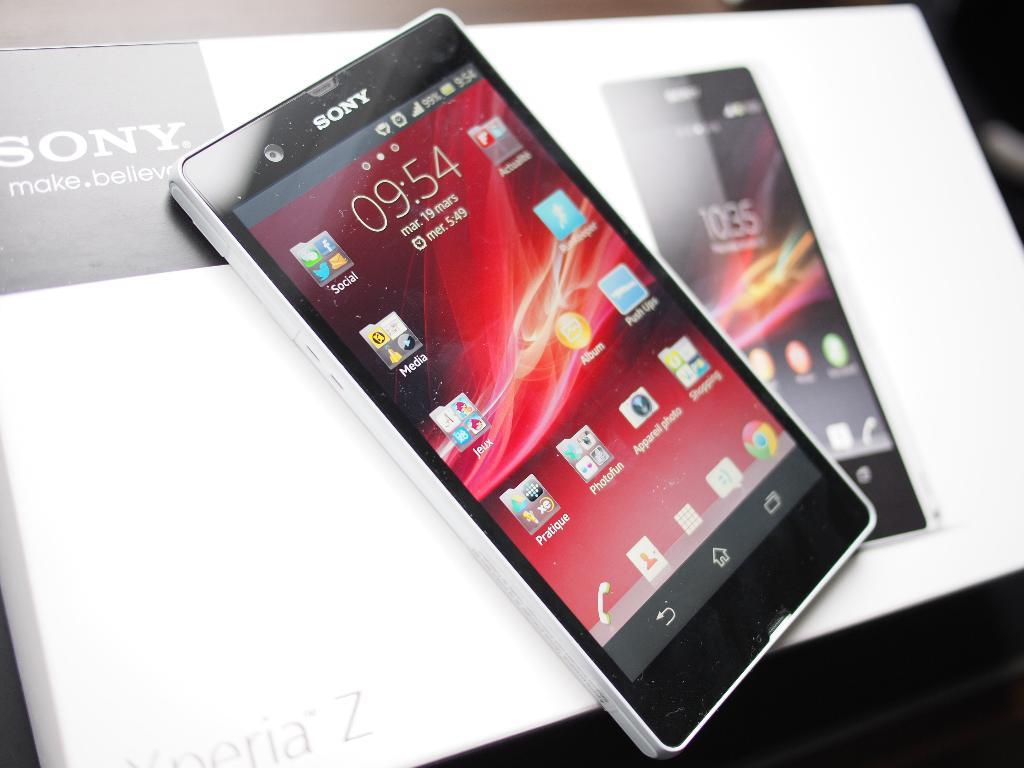<image>
Share a concise interpretation of the image provided. a phone that says the time is 9:54 on it 